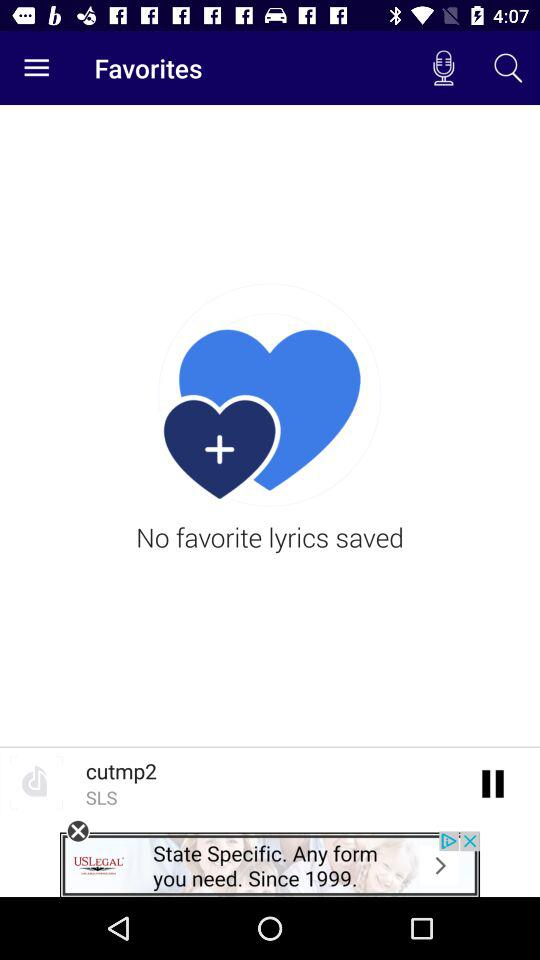Is there any favorite lyrics saved? There are no favorite lyrics saved. 